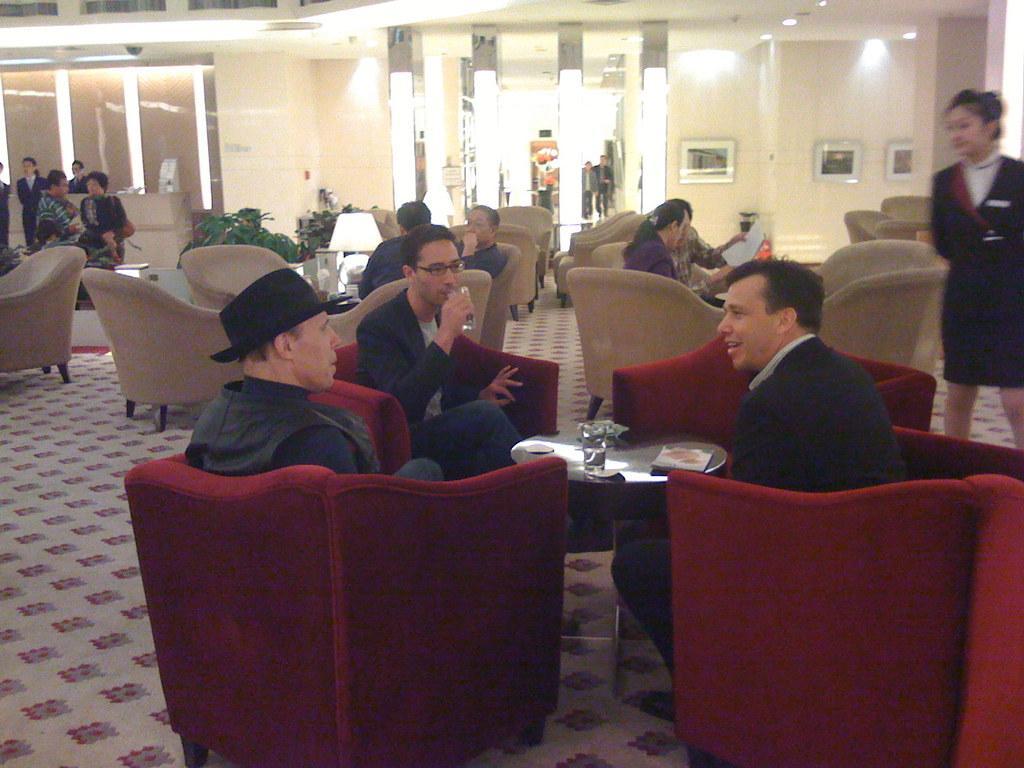Please provide a concise description of this image. In this image there are group of people. Few people are sitting on the couch. The person is sitting on the couch and drinking water. In front of the person there is a table,on table there is a lamp,glass of water and a book. The frames are attached on the wall. On the top of room there is a light. 